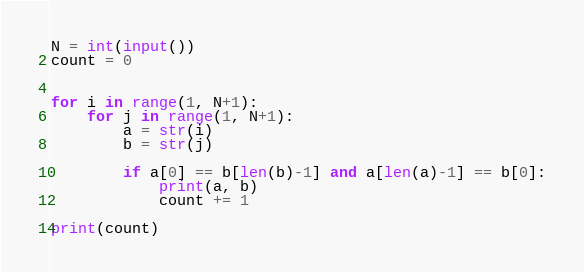Convert code to text. <code><loc_0><loc_0><loc_500><loc_500><_Python_>N = int(input())
count = 0


for i in range(1, N+1):
    for j in range(1, N+1):
        a = str(i)
        b = str(j)
        
        if a[0] == b[len(b)-1] and a[len(a)-1] == b[0]:
            print(a, b)
            count += 1

print(count)</code> 